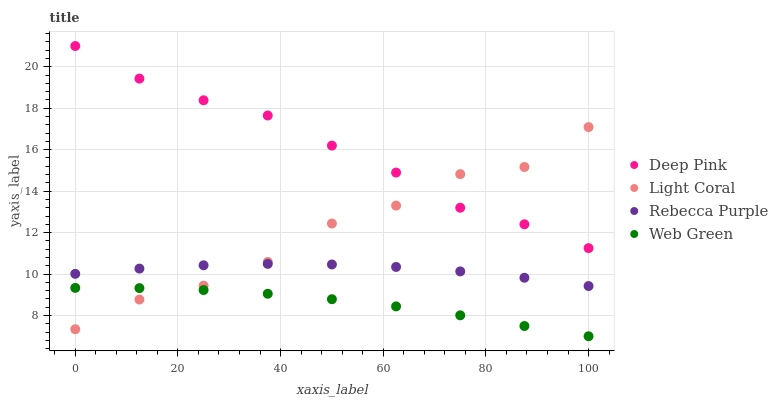Does Web Green have the minimum area under the curve?
Answer yes or no. Yes. Does Deep Pink have the maximum area under the curve?
Answer yes or no. Yes. Does Rebecca Purple have the minimum area under the curve?
Answer yes or no. No. Does Rebecca Purple have the maximum area under the curve?
Answer yes or no. No. Is Web Green the smoothest?
Answer yes or no. Yes. Is Light Coral the roughest?
Answer yes or no. Yes. Is Deep Pink the smoothest?
Answer yes or no. No. Is Deep Pink the roughest?
Answer yes or no. No. Does Web Green have the lowest value?
Answer yes or no. Yes. Does Rebecca Purple have the lowest value?
Answer yes or no. No. Does Deep Pink have the highest value?
Answer yes or no. Yes. Does Rebecca Purple have the highest value?
Answer yes or no. No. Is Web Green less than Rebecca Purple?
Answer yes or no. Yes. Is Rebecca Purple greater than Web Green?
Answer yes or no. Yes. Does Light Coral intersect Web Green?
Answer yes or no. Yes. Is Light Coral less than Web Green?
Answer yes or no. No. Is Light Coral greater than Web Green?
Answer yes or no. No. Does Web Green intersect Rebecca Purple?
Answer yes or no. No. 